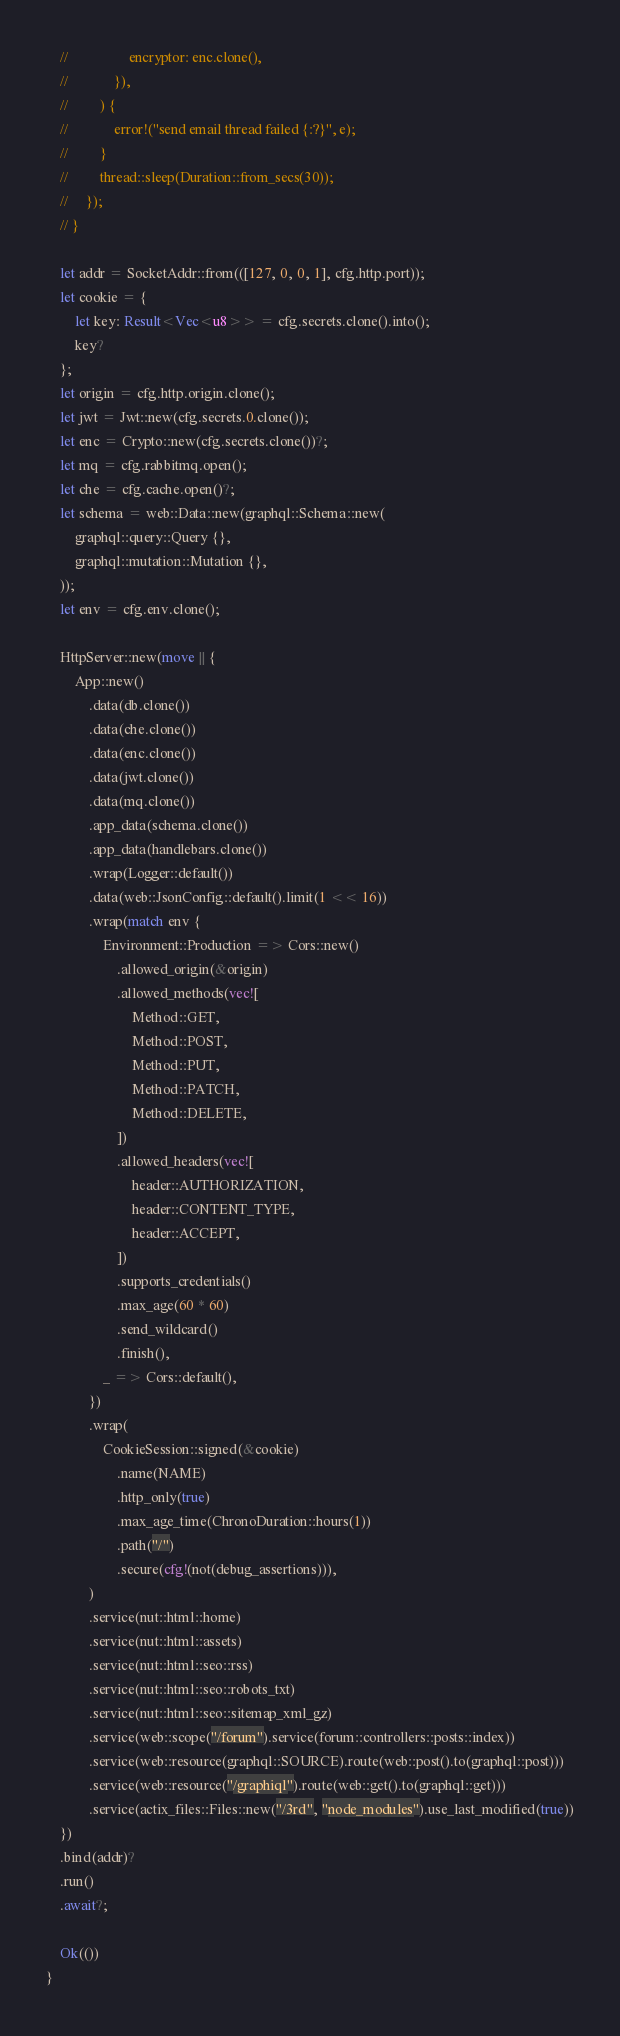<code> <loc_0><loc_0><loc_500><loc_500><_Rust_>    //                 encryptor: enc.clone(),
    //             }),
    //         ) {
    //             error!("send email thread failed {:?}", e);
    //         }
    //         thread::sleep(Duration::from_secs(30));
    //     });
    // }

    let addr = SocketAddr::from(([127, 0, 0, 1], cfg.http.port));
    let cookie = {
        let key: Result<Vec<u8>> = cfg.secrets.clone().into();
        key?
    };
    let origin = cfg.http.origin.clone();
    let jwt = Jwt::new(cfg.secrets.0.clone());
    let enc = Crypto::new(cfg.secrets.clone())?;
    let mq = cfg.rabbitmq.open();
    let che = cfg.cache.open()?;
    let schema = web::Data::new(graphql::Schema::new(
        graphql::query::Query {},
        graphql::mutation::Mutation {},
    ));
    let env = cfg.env.clone();

    HttpServer::new(move || {
        App::new()
            .data(db.clone())
            .data(che.clone())
            .data(enc.clone())
            .data(jwt.clone())
            .data(mq.clone())
            .app_data(schema.clone())
            .app_data(handlebars.clone())
            .wrap(Logger::default())
            .data(web::JsonConfig::default().limit(1 << 16))
            .wrap(match env {
                Environment::Production => Cors::new()
                    .allowed_origin(&origin)
                    .allowed_methods(vec![
                        Method::GET,
                        Method::POST,
                        Method::PUT,
                        Method::PATCH,
                        Method::DELETE,
                    ])
                    .allowed_headers(vec![
                        header::AUTHORIZATION,
                        header::CONTENT_TYPE,
                        header::ACCEPT,
                    ])
                    .supports_credentials()
                    .max_age(60 * 60)
                    .send_wildcard()
                    .finish(),
                _ => Cors::default(),
            })
            .wrap(
                CookieSession::signed(&cookie)
                    .name(NAME)
                    .http_only(true)
                    .max_age_time(ChronoDuration::hours(1))
                    .path("/")
                    .secure(cfg!(not(debug_assertions))),
            )
            .service(nut::html::home)
            .service(nut::html::assets)
            .service(nut::html::seo::rss)
            .service(nut::html::seo::robots_txt)
            .service(nut::html::seo::sitemap_xml_gz)
            .service(web::scope("/forum").service(forum::controllers::posts::index))
            .service(web::resource(graphql::SOURCE).route(web::post().to(graphql::post)))
            .service(web::resource("/graphiql").route(web::get().to(graphql::get)))
            .service(actix_files::Files::new("/3rd", "node_modules").use_last_modified(true))
    })
    .bind(addr)?
    .run()
    .await?;

    Ok(())
}
</code> 